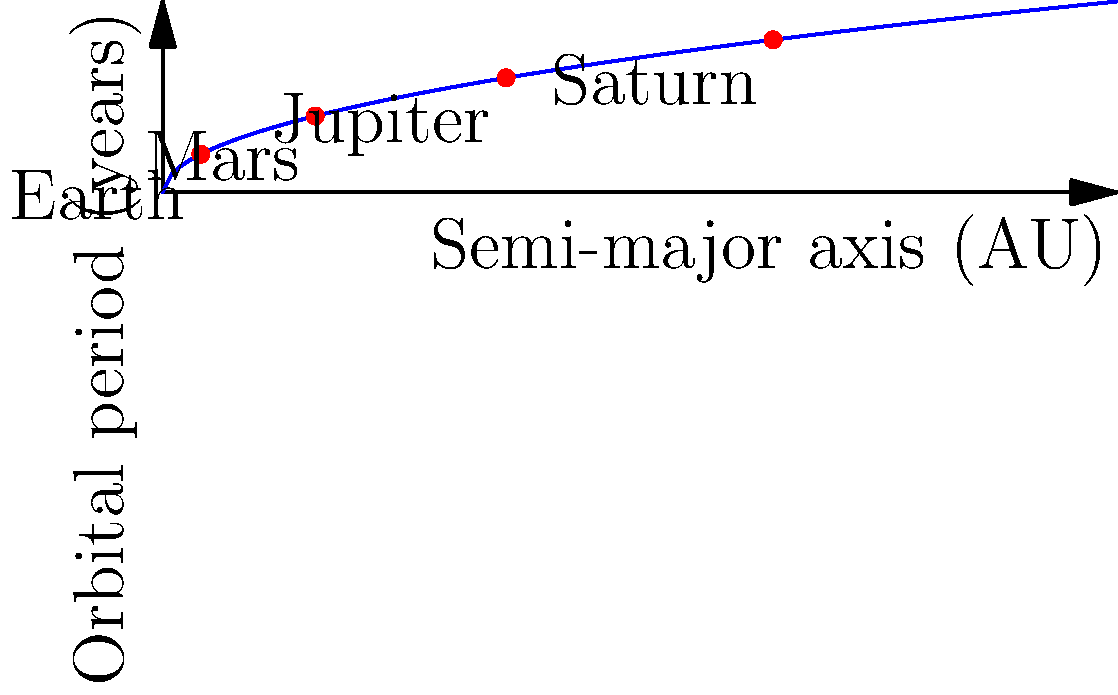As a researcher developing machine learning algorithms for biological data analysis, you're exploring astronomical principles that might have applications in your field. Using Kepler's Third Law, which states that the square of the orbital period of a planet is directly proportional to the cube of the semi-major axis of its orbit, calculate the orbital period of Neptune in years. Given that Neptune's semi-major axis is approximately 30.1 AU (Astronomical Units), and Earth's orbital period is 1 year with a semi-major axis of 1 AU, what is Neptune's orbital period? To solve this problem, we'll use Kepler's Third Law and the given information about Earth as a reference. Let's follow these steps:

1. Kepler's Third Law states: $T^2 \propto a^3$, where $T$ is the orbital period and $a$ is the semi-major axis.

2. We can write this as an equation: $\frac{T^2}{a^3} = k$ (constant for all planets in a system)

3. For Earth: $\frac{T_E^2}{a_E^3} = \frac{1^2}{1^3} = 1$

4. For Neptune: $\frac{T_N^2}{a_N^3} = 1$ (same constant as Earth)

5. We can set up the equation: $\frac{T_N^2}{30.1^3} = \frac{1^2}{1^3}$

6. Simplify: $T_N^2 = 30.1^3$

7. Solve for $T_N$: $T_N = \sqrt{30.1^3} \approx 164.8$

Therefore, Neptune's orbital period is approximately 164.8 years.
Answer: 164.8 years 